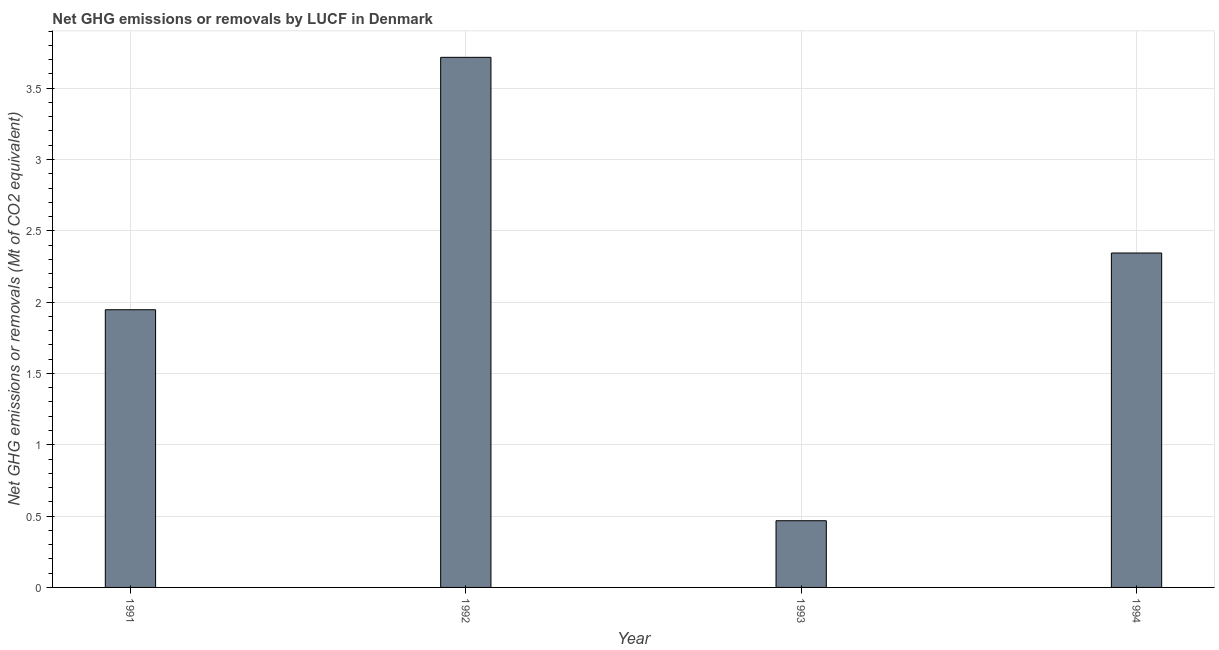Does the graph contain grids?
Your answer should be very brief. Yes. What is the title of the graph?
Ensure brevity in your answer.  Net GHG emissions or removals by LUCF in Denmark. What is the label or title of the Y-axis?
Provide a succinct answer. Net GHG emissions or removals (Mt of CO2 equivalent). What is the ghg net emissions or removals in 1992?
Make the answer very short. 3.72. Across all years, what is the maximum ghg net emissions or removals?
Give a very brief answer. 3.72. Across all years, what is the minimum ghg net emissions or removals?
Your answer should be very brief. 0.47. What is the sum of the ghg net emissions or removals?
Keep it short and to the point. 8.47. What is the difference between the ghg net emissions or removals in 1991 and 1994?
Your answer should be compact. -0.4. What is the average ghg net emissions or removals per year?
Provide a short and direct response. 2.12. What is the median ghg net emissions or removals?
Your answer should be very brief. 2.15. In how many years, is the ghg net emissions or removals greater than 3.2 Mt?
Your answer should be compact. 1. What is the ratio of the ghg net emissions or removals in 1992 to that in 1994?
Provide a succinct answer. 1.58. Is the ghg net emissions or removals in 1992 less than that in 1993?
Give a very brief answer. No. What is the difference between the highest and the second highest ghg net emissions or removals?
Provide a succinct answer. 1.37. Is the sum of the ghg net emissions or removals in 1991 and 1992 greater than the maximum ghg net emissions or removals across all years?
Your response must be concise. Yes. What is the difference between the highest and the lowest ghg net emissions or removals?
Your answer should be compact. 3.25. In how many years, is the ghg net emissions or removals greater than the average ghg net emissions or removals taken over all years?
Keep it short and to the point. 2. How many years are there in the graph?
Your response must be concise. 4. What is the Net GHG emissions or removals (Mt of CO2 equivalent) in 1991?
Your response must be concise. 1.95. What is the Net GHG emissions or removals (Mt of CO2 equivalent) in 1992?
Your answer should be compact. 3.72. What is the Net GHG emissions or removals (Mt of CO2 equivalent) in 1993?
Your answer should be compact. 0.47. What is the Net GHG emissions or removals (Mt of CO2 equivalent) of 1994?
Give a very brief answer. 2.34. What is the difference between the Net GHG emissions or removals (Mt of CO2 equivalent) in 1991 and 1992?
Keep it short and to the point. -1.77. What is the difference between the Net GHG emissions or removals (Mt of CO2 equivalent) in 1991 and 1993?
Your answer should be compact. 1.48. What is the difference between the Net GHG emissions or removals (Mt of CO2 equivalent) in 1991 and 1994?
Ensure brevity in your answer.  -0.4. What is the difference between the Net GHG emissions or removals (Mt of CO2 equivalent) in 1992 and 1993?
Offer a terse response. 3.25. What is the difference between the Net GHG emissions or removals (Mt of CO2 equivalent) in 1992 and 1994?
Keep it short and to the point. 1.37. What is the difference between the Net GHG emissions or removals (Mt of CO2 equivalent) in 1993 and 1994?
Give a very brief answer. -1.88. What is the ratio of the Net GHG emissions or removals (Mt of CO2 equivalent) in 1991 to that in 1992?
Give a very brief answer. 0.52. What is the ratio of the Net GHG emissions or removals (Mt of CO2 equivalent) in 1991 to that in 1993?
Make the answer very short. 4.16. What is the ratio of the Net GHG emissions or removals (Mt of CO2 equivalent) in 1991 to that in 1994?
Offer a terse response. 0.83. What is the ratio of the Net GHG emissions or removals (Mt of CO2 equivalent) in 1992 to that in 1993?
Give a very brief answer. 7.95. What is the ratio of the Net GHG emissions or removals (Mt of CO2 equivalent) in 1992 to that in 1994?
Offer a very short reply. 1.58. What is the ratio of the Net GHG emissions or removals (Mt of CO2 equivalent) in 1993 to that in 1994?
Provide a short and direct response. 0.2. 